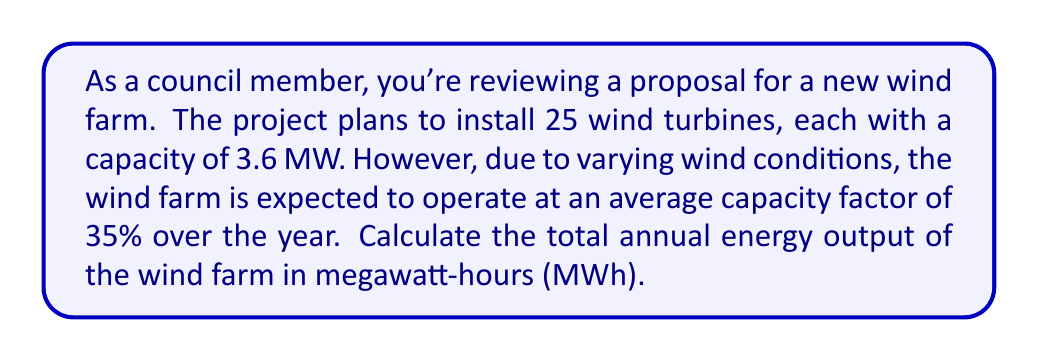Show me your answer to this math problem. To solve this problem, we'll follow these steps:

1. Calculate the total installed capacity of the wind farm:
   $$\text{Total Capacity} = \text{Number of Turbines} \times \text{Capacity per Turbine}$$
   $$\text{Total Capacity} = 25 \times 3.6 \text{ MW} = 90 \text{ MW}$$

2. Calculate the actual power output considering the capacity factor:
   $$\text{Actual Power Output} = \text{Total Capacity} \times \text{Capacity Factor}$$
   $$\text{Actual Power Output} = 90 \text{ MW} \times 0.35 = 31.5 \text{ MW}$$

3. Calculate the annual energy output:
   $$\text{Annual Energy Output} = \text{Actual Power Output} \times \text{Hours in a Year}$$
   $$\text{Annual Energy Output} = 31.5 \text{ MW} \times (365 \text{ days} \times 24 \text{ hours/day})$$
   $$\text{Annual Energy Output} = 31.5 \text{ MW} \times 8760 \text{ hours}$$
   $$\text{Annual Energy Output} = 275,940 \text{ MWh}$$
Answer: The total annual energy output of the wind farm is 275,940 MWh. 